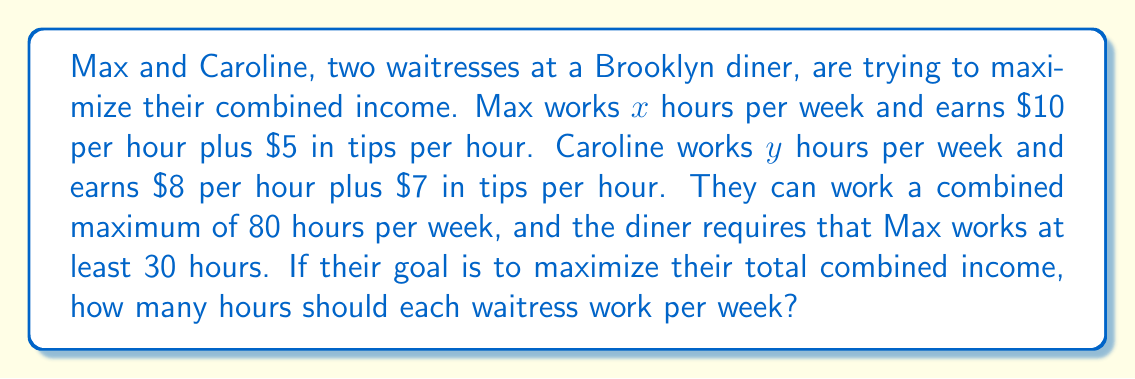Show me your answer to this math problem. Let's approach this step-by-step:

1) First, we need to set up equations for each waitress's income:
   Max's income: $15x$ (wage + tips per hour multiplied by hours worked)
   Caroline's income: $15y$ (wage + tips per hour multiplied by hours worked)

2) The objective is to maximize their combined income:
   $$ \text{Maximize: } 15x + 15y $$

3) Now, let's consider the constraints:
   Total hours: $x + y \leq 80$
   Max's minimum hours: $x \geq 30$
   Non-negativity: $x \geq 0, y \geq 0$

4) This is a linear programming problem. The optimal solution will be at one of the corner points of the feasible region.

5) The corner points are:
   (30, 50), (80, 0), and (30, 0)

6) Let's evaluate the objective function at each point:
   At (30, 50): $15(30) + 15(50) = 1200$
   At (80, 0): $15(80) + 15(0) = 1200$
   At (30, 0): $15(30) + 15(0) = 450$

7) The maximum value occurs at both (30, 50) and (80, 0), but since the diner requires Max to work at least 30 hours, we'll choose (30, 50).

Therefore, to maximize their combined income, Max should work 30 hours and Caroline should work 50 hours per week.
Answer: Max should work 30 hours and Caroline should work 50 hours per week. 